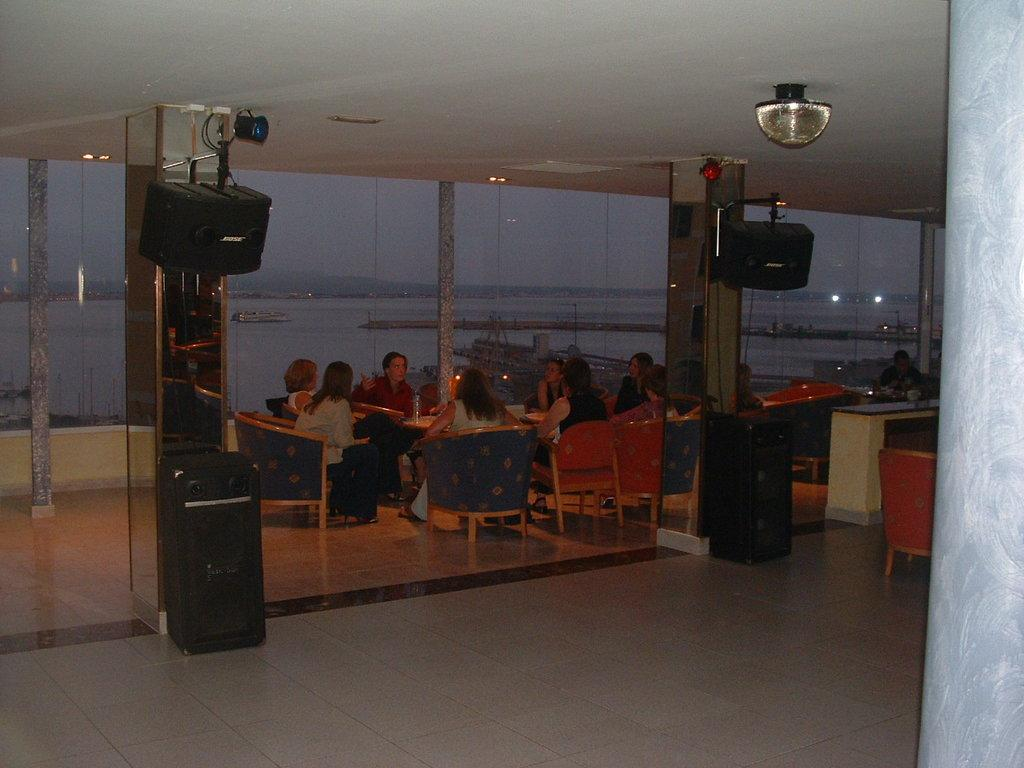What is visible in the image? Water is visible in the image. What are the people in the image doing? The people in the image are sitting on chairs. What type of furniture is present in the image? There are tables in the image. What is the color and material of the floor in the image? The floor in the image is covered with white color tiles. What type of sack is being used by the people in the image? There is no sack present in the image; the people are sitting on chairs. What are the people talking about in the image? The image does not provide any information about what the people are talking about. 